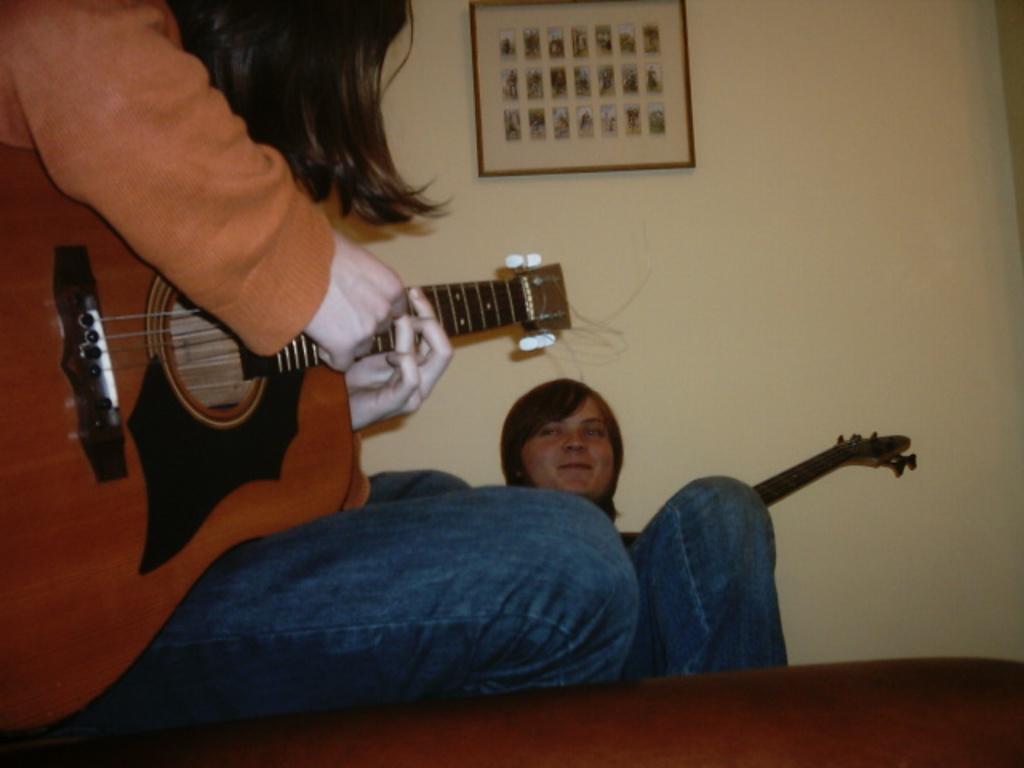In one or two sentences, can you explain what this image depicts? This picture is clicked in a room. There are two persons, one woman and one man. Woman is wearing orange sweater with blue sweater, she is sitting in a sofa and playing a guitar and man watching her. in the background there is a wall and a frame hanging to it. 